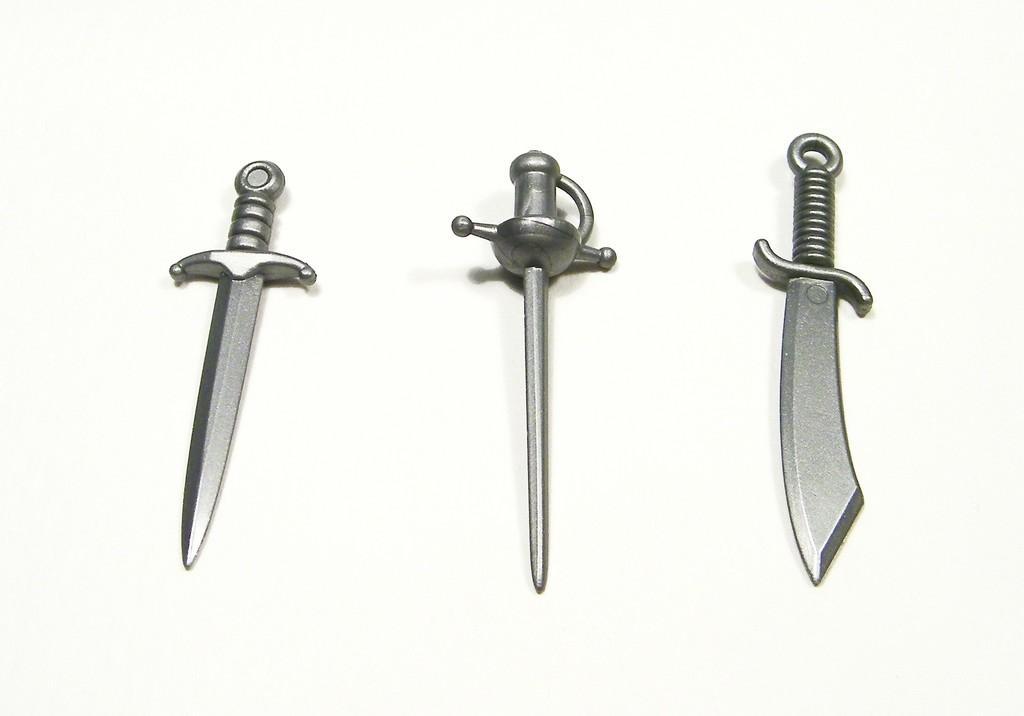Can you describe this image briefly? In this image three swords are kept on the floor. 